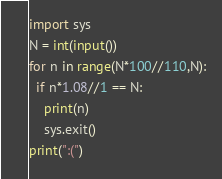<code> <loc_0><loc_0><loc_500><loc_500><_Python_>import sys
N = int(input())
for n in range(N*100//110,N):
  if n*1.08//1 == N:
    print(n)
    sys.exit()
print(":(")</code> 